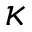<formula> <loc_0><loc_0><loc_500><loc_500>\kappa</formula> 